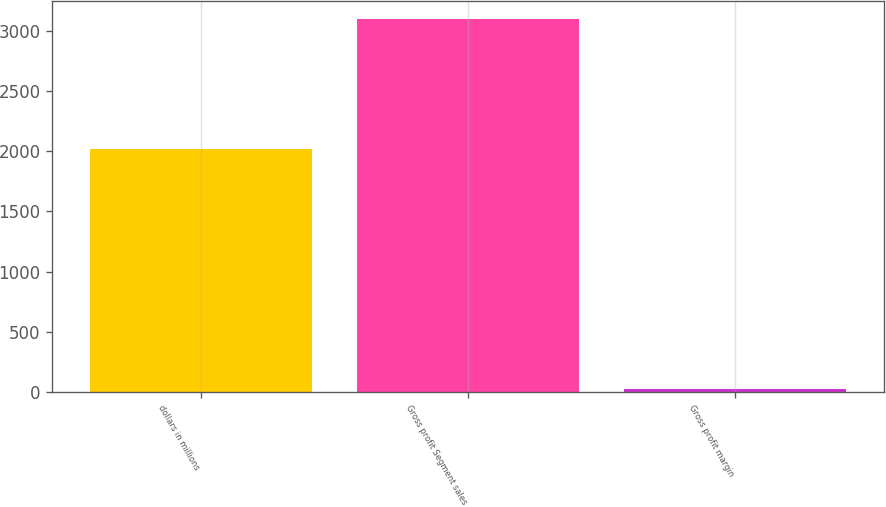Convert chart. <chart><loc_0><loc_0><loc_500><loc_500><bar_chart><fcel>dollars in millions<fcel>Gross profit Segment sales<fcel>Gross profit margin<nl><fcel>2017<fcel>3096.1<fcel>27.6<nl></chart> 